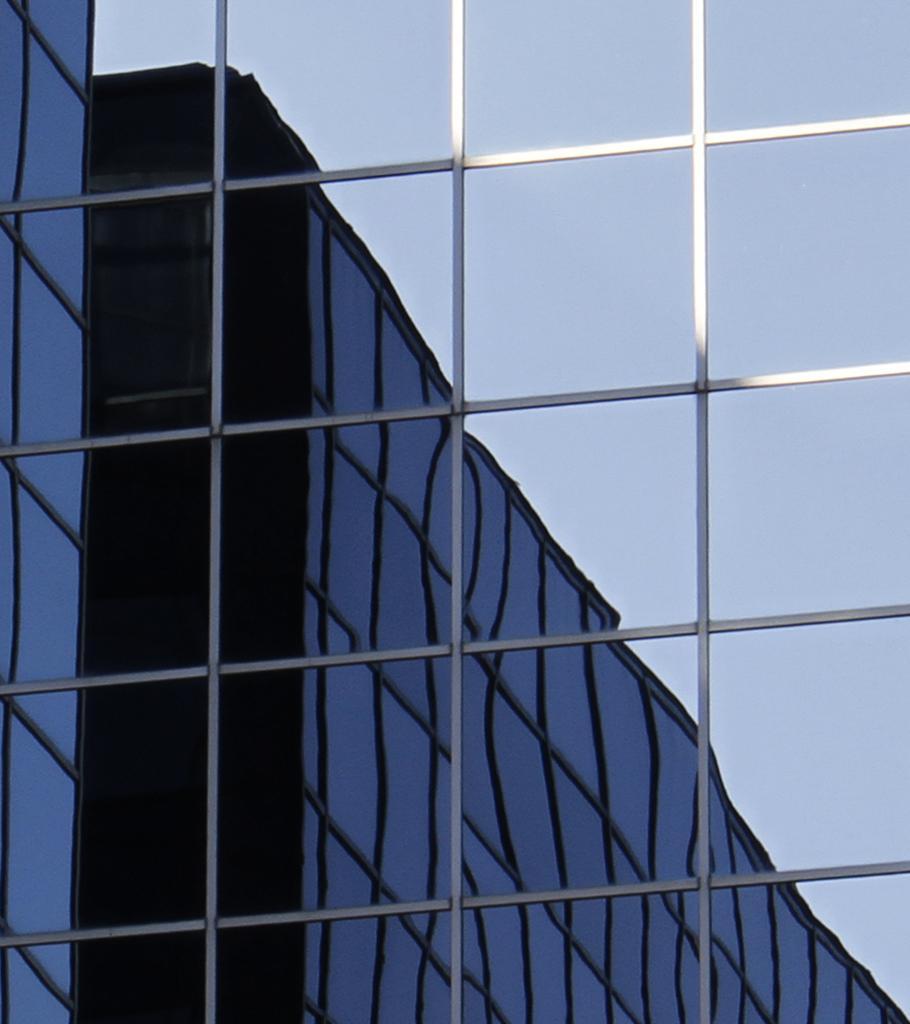How would you summarize this image in a sentence or two? In this picture i can see the glass on the wall. In that reflection i can see the building and sky. 